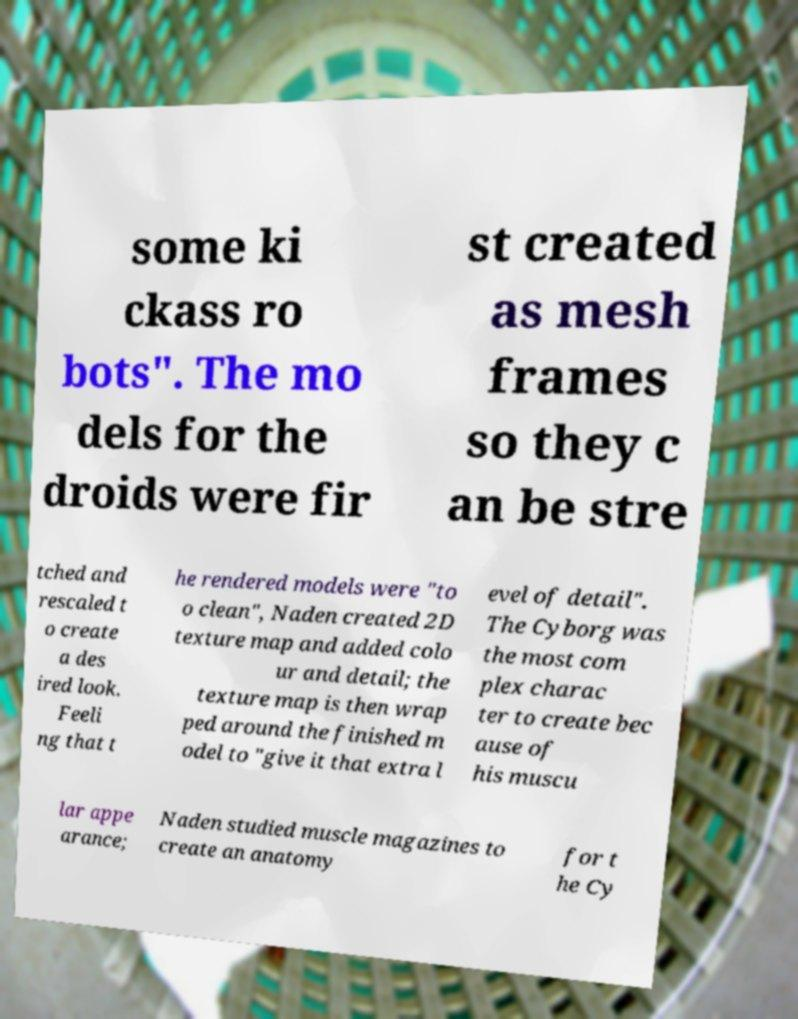Please identify and transcribe the text found in this image. some ki ckass ro bots". The mo dels for the droids were fir st created as mesh frames so they c an be stre tched and rescaled t o create a des ired look. Feeli ng that t he rendered models were "to o clean", Naden created 2D texture map and added colo ur and detail; the texture map is then wrap ped around the finished m odel to "give it that extra l evel of detail". The Cyborg was the most com plex charac ter to create bec ause of his muscu lar appe arance; Naden studied muscle magazines to create an anatomy for t he Cy 